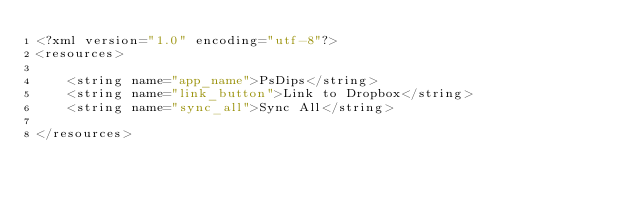<code> <loc_0><loc_0><loc_500><loc_500><_XML_><?xml version="1.0" encoding="utf-8"?>
<resources>

    <string name="app_name">PsDips</string>
    <string name="link_button">Link to Dropbox</string>
    <string name="sync_all">Sync All</string>

</resources></code> 